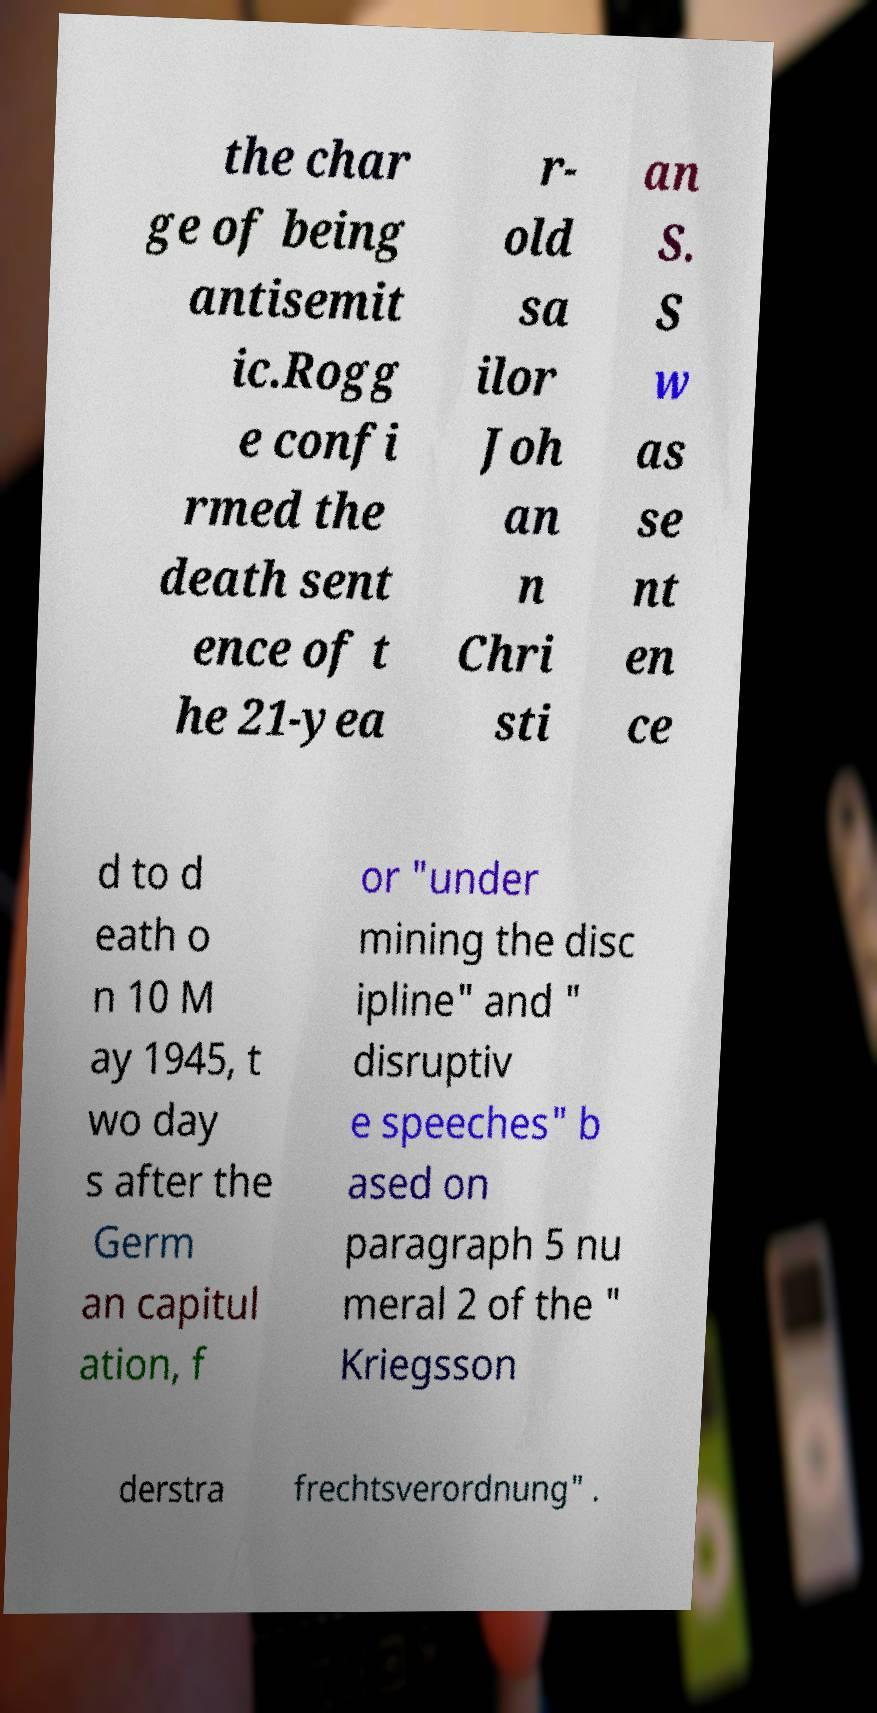There's text embedded in this image that I need extracted. Can you transcribe it verbatim? the char ge of being antisemit ic.Rogg e confi rmed the death sent ence of t he 21-yea r- old sa ilor Joh an n Chri sti an S. S w as se nt en ce d to d eath o n 10 M ay 1945, t wo day s after the Germ an capitul ation, f or "under mining the disc ipline" and " disruptiv e speeches" b ased on paragraph 5 nu meral 2 of the " Kriegsson derstra frechtsverordnung" . 